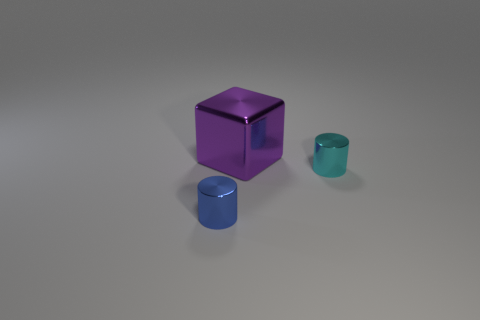What is the shape of the other cyan object that is the same material as the big object?
Keep it short and to the point. Cylinder. How many big objects are purple spheres or metal blocks?
Your answer should be very brief. 1. How many other things are there of the same color as the big shiny object?
Give a very brief answer. 0. What number of large blocks are to the left of the metal cylinder in front of the metallic cylinder on the right side of the blue shiny thing?
Provide a short and direct response. 0. Do the thing behind the cyan metal cylinder and the tiny cyan cylinder have the same size?
Give a very brief answer. No. Are there fewer cyan cylinders behind the small cyan object than small cyan shiny cylinders in front of the small blue cylinder?
Ensure brevity in your answer.  No. Is the number of cyan metal things that are in front of the small cyan shiny cylinder less than the number of large things?
Keep it short and to the point. Yes. Is the material of the big purple cube the same as the blue cylinder?
Provide a succinct answer. Yes. What number of other red blocks are made of the same material as the large cube?
Your response must be concise. 0. What color is the block that is the same material as the cyan cylinder?
Your answer should be compact. Purple. 